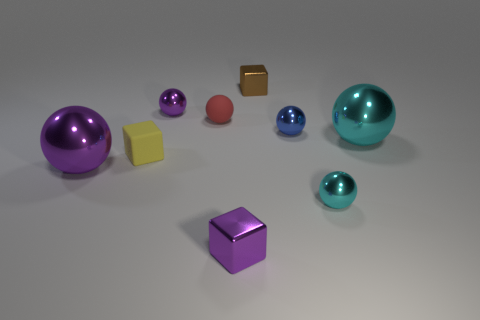Subtract all purple balls. How many balls are left? 4 Subtract all rubber balls. How many balls are left? 5 Subtract all yellow spheres. Subtract all brown blocks. How many spheres are left? 6 Subtract all blocks. How many objects are left? 6 Add 1 tiny matte things. How many tiny matte things are left? 3 Add 2 purple things. How many purple things exist? 5 Subtract 1 yellow cubes. How many objects are left? 8 Subtract all small yellow matte cubes. Subtract all tiny purple metallic spheres. How many objects are left? 7 